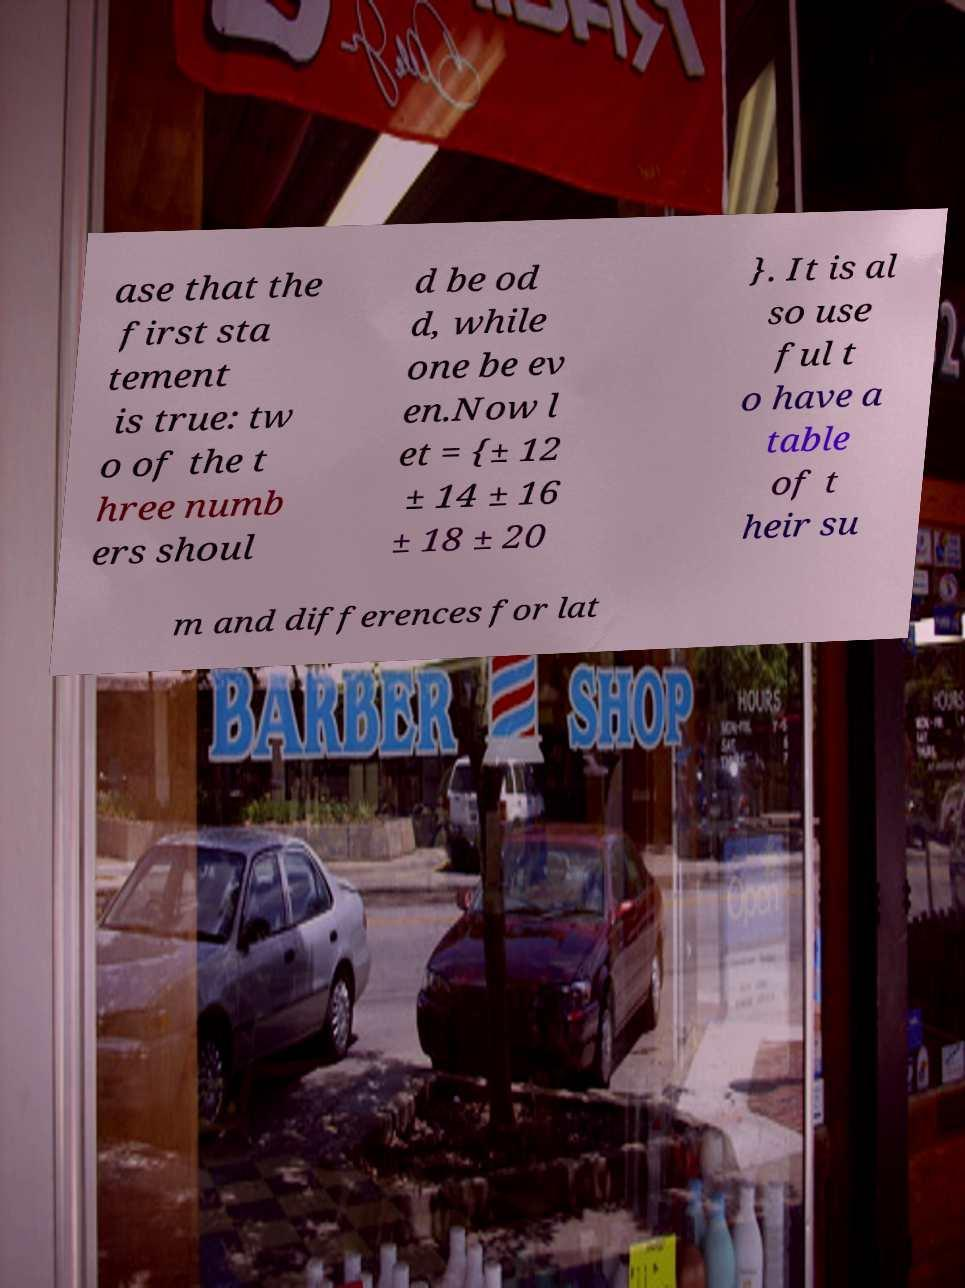Can you accurately transcribe the text from the provided image for me? ase that the first sta tement is true: tw o of the t hree numb ers shoul d be od d, while one be ev en.Now l et = {± 12 ± 14 ± 16 ± 18 ± 20 }. It is al so use ful t o have a table of t heir su m and differences for lat 